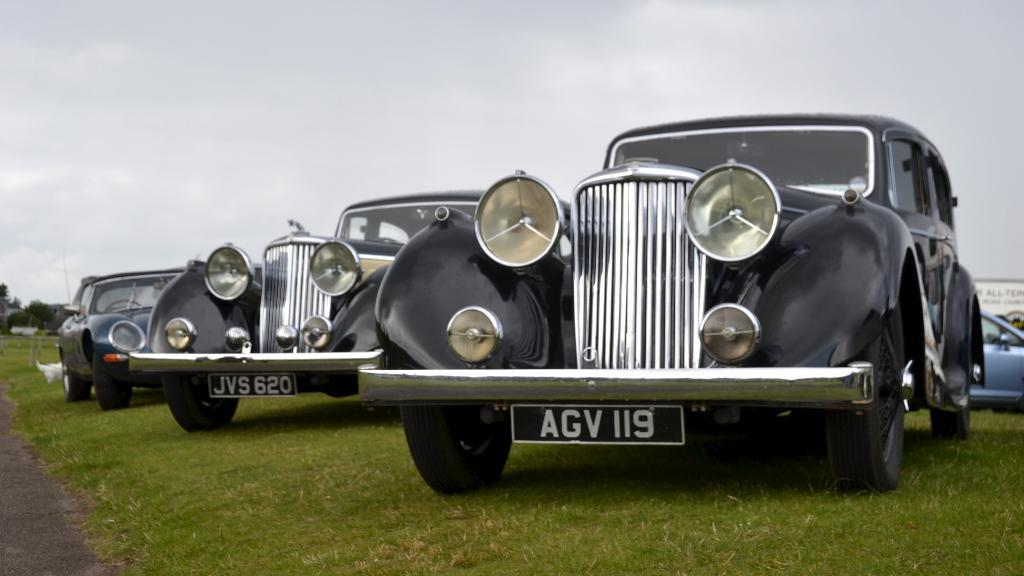What can be seen on the ground in the image? There are vehicles on the ground in the image. What is visible in the sky in the background? There are clouds visible in the sky in the background. What is located on the left side of the image? There is a tree, a road, and other objects on the left side of the image. What is present on the right side of the image? There is a hoarding on the right side of the image. Can you tell me how many roots are visible on the tree in the image? There is no mention of roots in the provided facts, and therefore we cannot determine the number of roots visible on the tree in the image. What type of question is being asked by the hoarding in the image? There is no indication that the hoarding is asking a question in the image. 